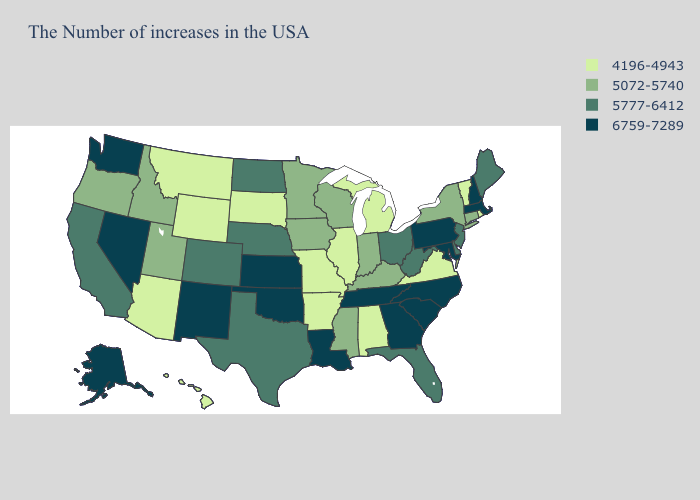Does Wisconsin have the highest value in the MidWest?
Be succinct. No. What is the lowest value in states that border New York?
Give a very brief answer. 4196-4943. Does Pennsylvania have the highest value in the Northeast?
Concise answer only. Yes. What is the value of Arizona?
Short answer required. 4196-4943. What is the value of Iowa?
Keep it brief. 5072-5740. Does North Carolina have the highest value in the USA?
Short answer required. Yes. What is the value of New Mexico?
Be succinct. 6759-7289. What is the value of Iowa?
Answer briefly. 5072-5740. Does New Hampshire have the same value as Georgia?
Answer briefly. Yes. What is the highest value in states that border Pennsylvania?
Write a very short answer. 6759-7289. What is the highest value in the USA?
Quick response, please. 6759-7289. What is the highest value in states that border Wyoming?
Quick response, please. 5777-6412. Name the states that have a value in the range 5072-5740?
Concise answer only. Connecticut, New York, Kentucky, Indiana, Wisconsin, Mississippi, Minnesota, Iowa, Utah, Idaho, Oregon. Name the states that have a value in the range 4196-4943?
Be succinct. Rhode Island, Vermont, Virginia, Michigan, Alabama, Illinois, Missouri, Arkansas, South Dakota, Wyoming, Montana, Arizona, Hawaii. How many symbols are there in the legend?
Keep it brief. 4. 